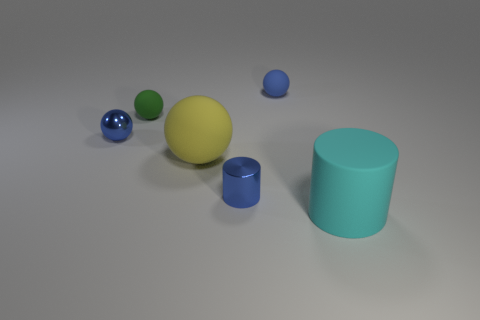How many other things are there of the same material as the big yellow object?
Your response must be concise. 3. There is a cylinder to the left of the tiny sphere behind the tiny green thing; how many big rubber objects are behind it?
Offer a terse response. 1. What number of metallic objects are either purple things or tiny blue cylinders?
Give a very brief answer. 1. There is a thing on the right side of the matte object that is behind the small green object; how big is it?
Your answer should be very brief. Large. There is a small rubber sphere that is left of the small shiny cylinder; is it the same color as the big object that is left of the matte cylinder?
Your response must be concise. No. What color is the small thing that is behind the small blue cylinder and right of the green matte sphere?
Ensure brevity in your answer.  Blue. Do the cyan thing and the large yellow object have the same material?
Provide a short and direct response. Yes. How many big things are either brown balls or spheres?
Offer a terse response. 1. Is there anything else that has the same shape as the small green rubber thing?
Provide a short and direct response. Yes. Is there anything else that is the same size as the blue cylinder?
Your response must be concise. Yes. 